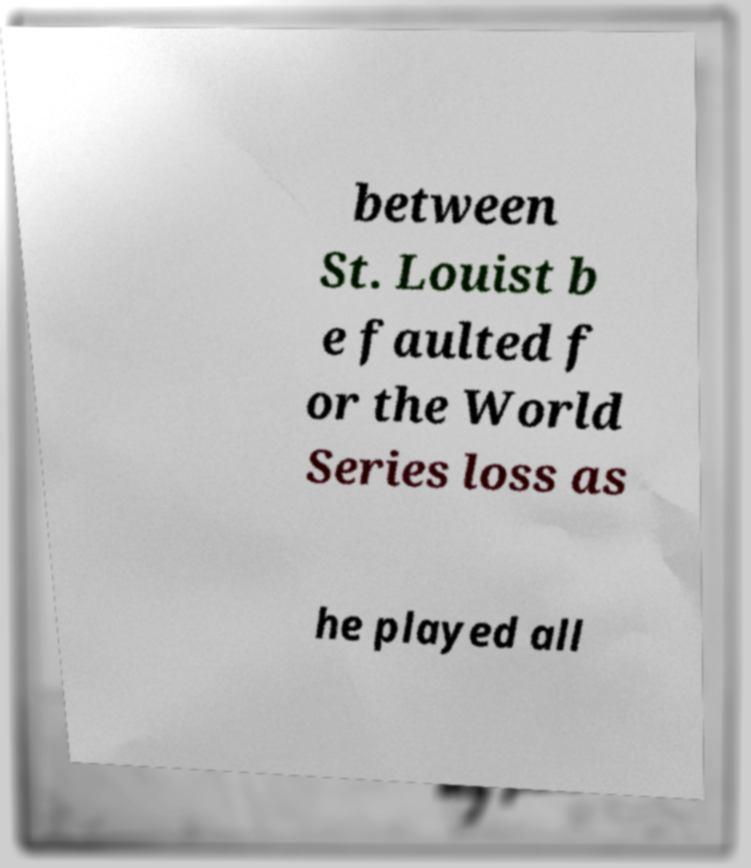Could you extract and type out the text from this image? between St. Louist b e faulted f or the World Series loss as he played all 